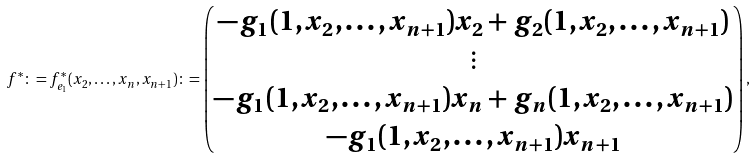Convert formula to latex. <formula><loc_0><loc_0><loc_500><loc_500>f ^ { * } \colon = f ^ { * } _ { e _ { 1 } } ( x _ { 2 } , \dots , x _ { n } , x _ { n + 1 } ) \colon = \begin{pmatrix} - g _ { 1 } ( 1 , x _ { 2 } , \dots , x _ { n + 1 } ) x _ { 2 } + g _ { 2 } ( 1 , x _ { 2 } , \dots , x _ { n + 1 } ) \\ \vdots \\ - g _ { 1 } ( 1 , x _ { 2 } , \dots , x _ { n + 1 } ) x _ { n } + g _ { n } ( 1 , x _ { 2 } , \dots , x _ { n + 1 } ) \\ - g _ { 1 } ( 1 , x _ { 2 } , \dots , x _ { n + 1 } ) x _ { n + 1 } \end{pmatrix} ,</formula> 